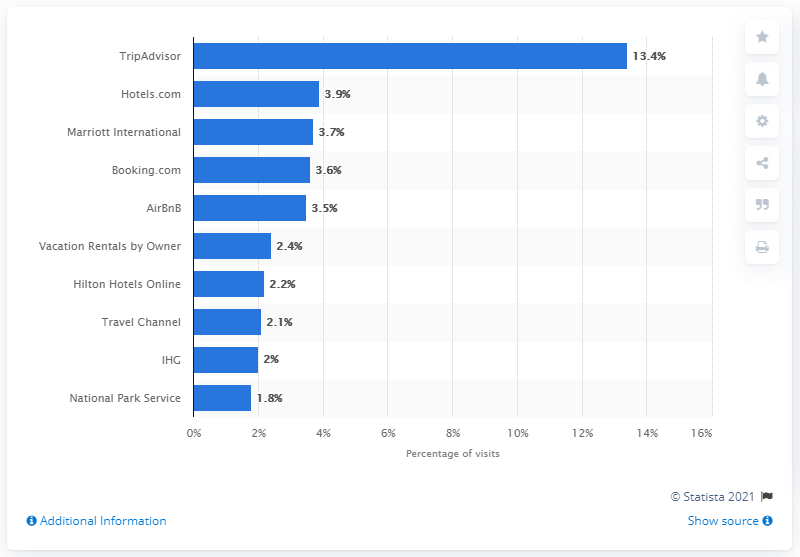Highlight a few significant elements in this photo. In November 2016, TripAdvisor was the largest travel website in the United States. 